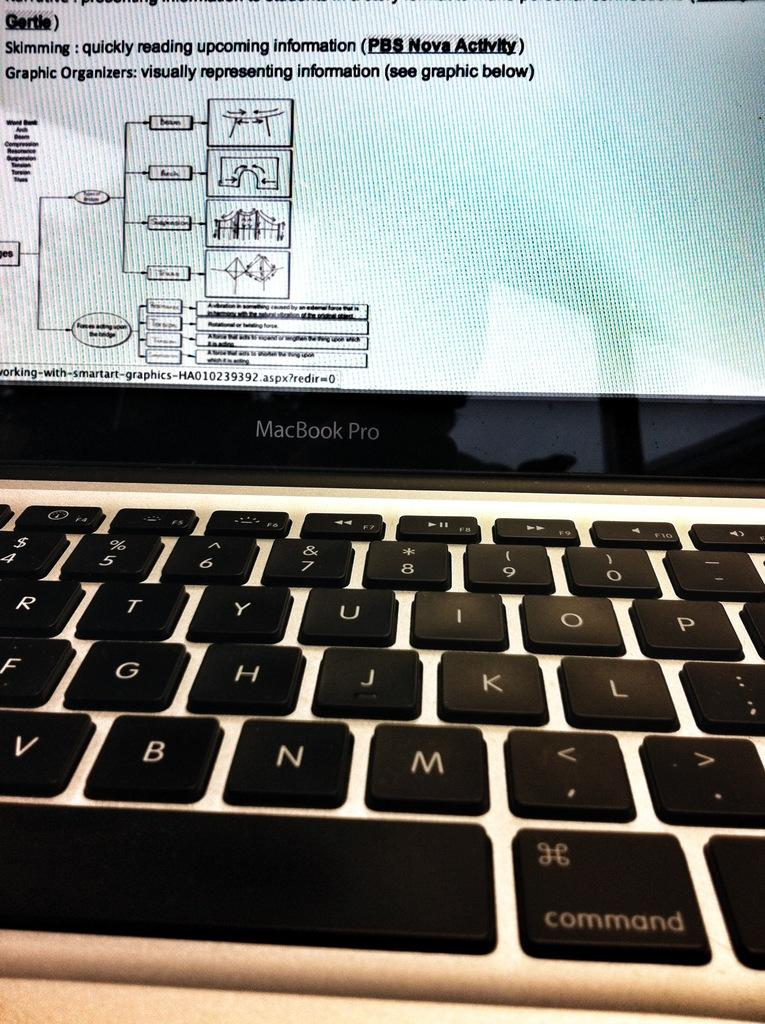Provide a one-sentence caption for the provided image. A MacBook Pro monitor displays definitions of skimming and graphic organizers. 